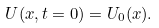<formula> <loc_0><loc_0><loc_500><loc_500>U ( x , t = 0 ) = U _ { 0 } ( x ) .</formula> 